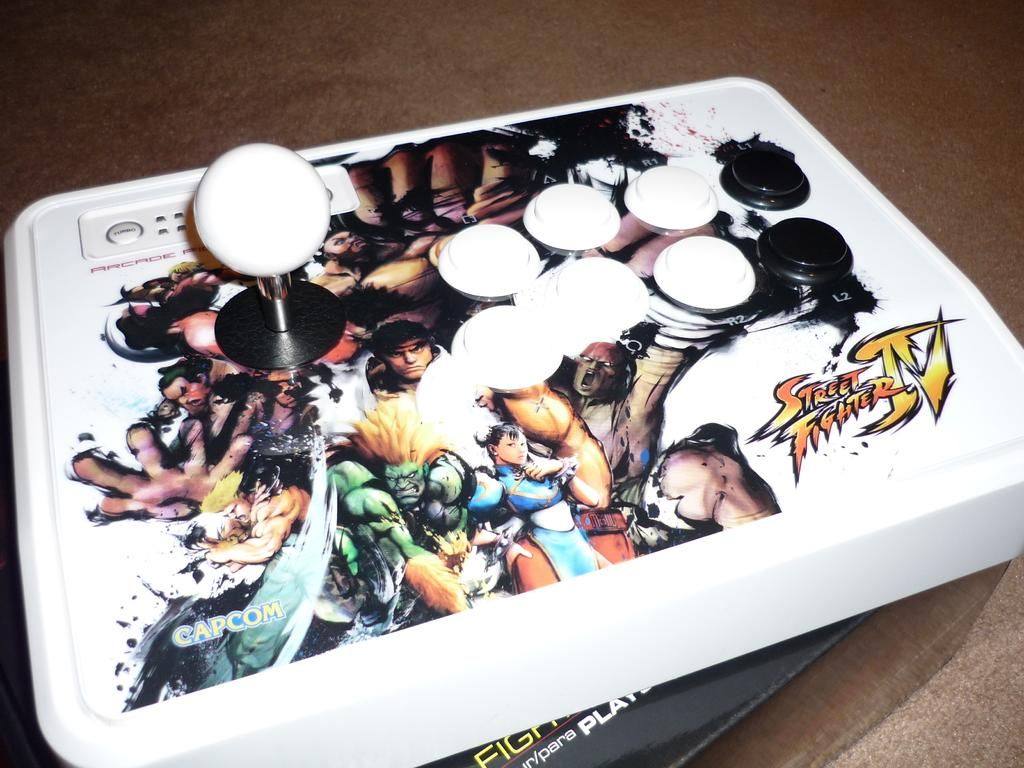What object is the main focus of the image? There is a joystick in the image. Where is the joystick located? The joystick is placed on a table. What type of cart is being used by the government in the image? There is no cart or reference to the government present in the image; it only features a joystick on a table. 